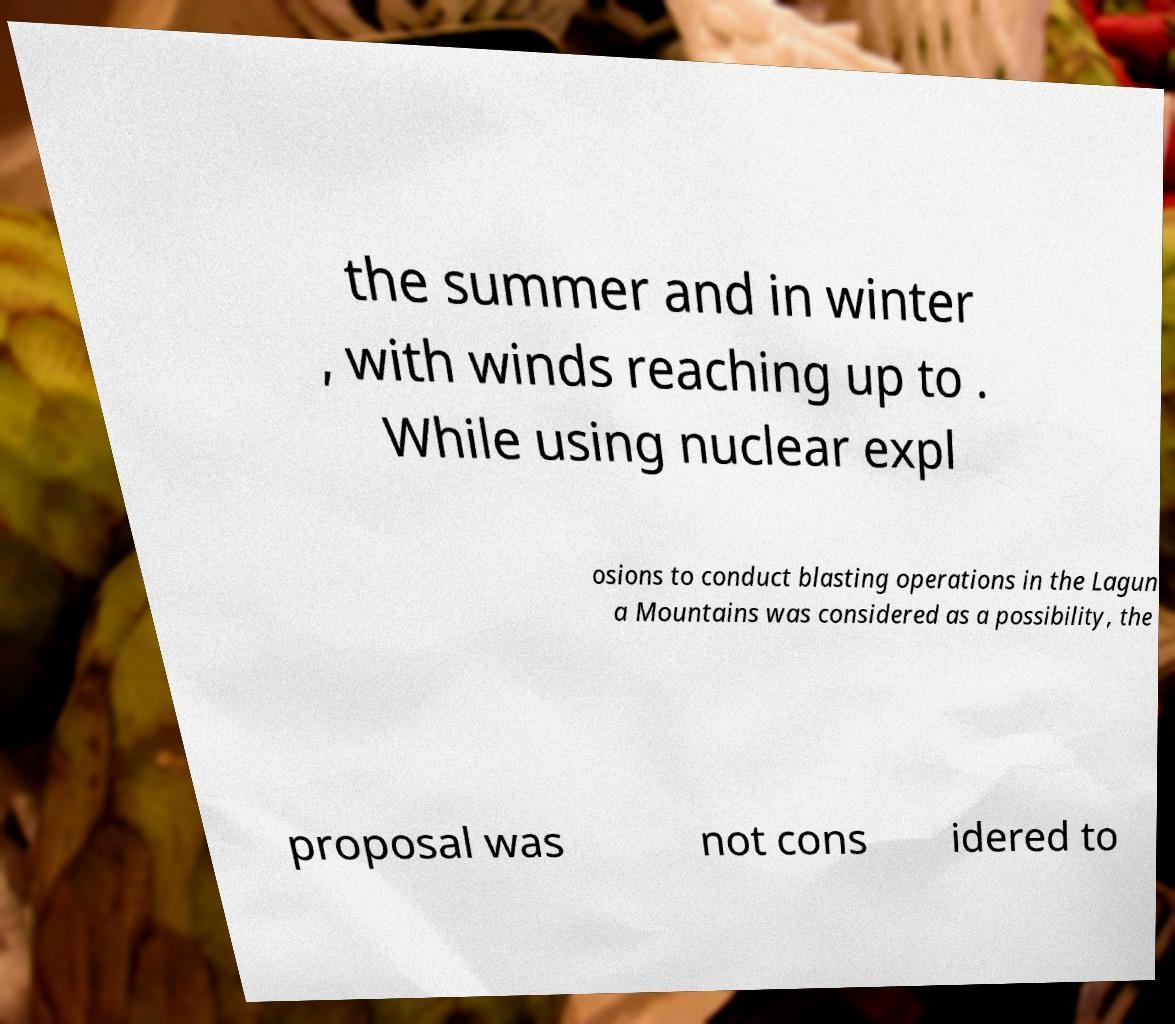For documentation purposes, I need the text within this image transcribed. Could you provide that? the summer and in winter , with winds reaching up to . While using nuclear expl osions to conduct blasting operations in the Lagun a Mountains was considered as a possibility, the proposal was not cons idered to 